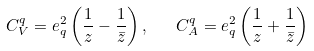<formula> <loc_0><loc_0><loc_500><loc_500>C _ { V } ^ { q } = e _ { q } ^ { 2 } \left ( \frac { 1 } { z } - \frac { 1 } { \bar { z } } \right ) , \quad C _ { A } ^ { q } = e _ { q } ^ { 2 } \left ( \frac { 1 } { z } + \frac { 1 } { \bar { z } } \right )</formula> 